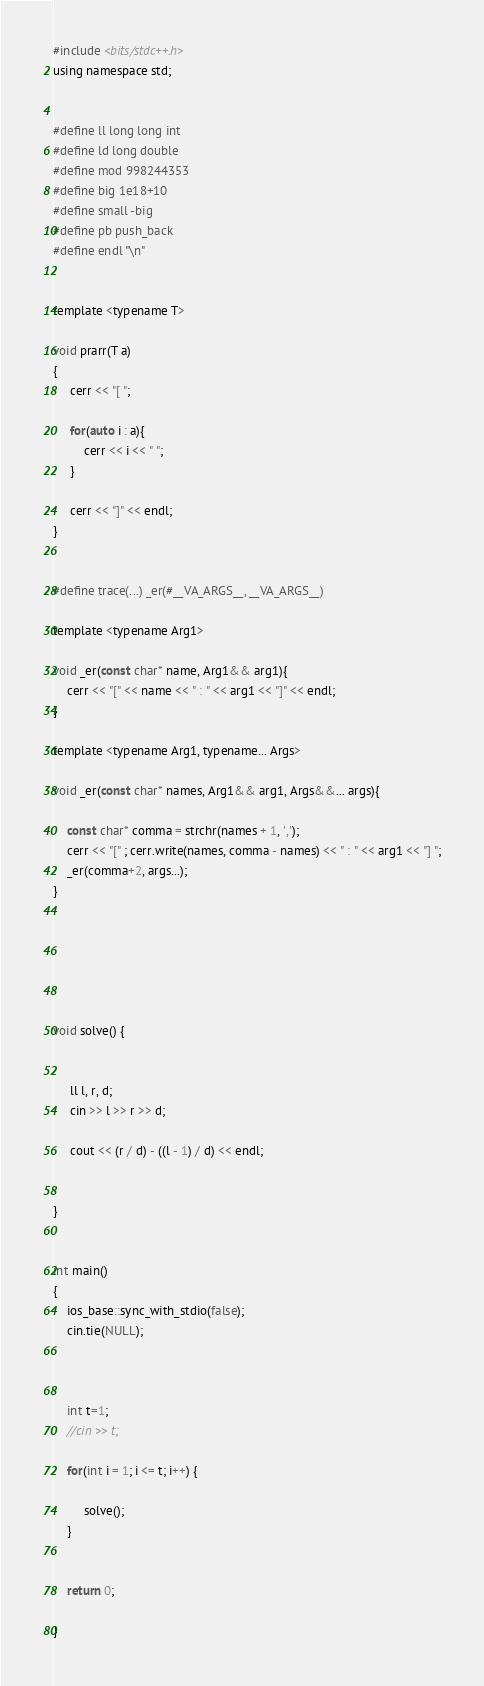<code> <loc_0><loc_0><loc_500><loc_500><_C_>

#include <bits/stdc++.h>
using namespace std;


#define ll long long int
#define ld long double
#define mod 998244353
#define big 1e18+10
#define small -big
#define pb push_back
#define endl "\n"


template <typename T>

void prarr(T a)
{
     cerr << "[ ";
     
     for(auto i : a){
         cerr << i << " ";
     }
     
     cerr << "]" << endl;
}


#define trace(...) _er(#__VA_ARGS__, __VA_ARGS__)

template <typename Arg1>

void _er(const char* name, Arg1&& arg1){
	cerr << "[" << name << " : " << arg1 << "]" << endl;
}

template <typename Arg1, typename... Args>

void _er(const char* names, Arg1&& arg1, Args&&... args){
    
	const char* comma = strchr(names + 1, ',');
	cerr << "[" ; cerr.write(names, comma - names) << " : " << arg1 << "] ";
	_er(comma+2, args...);
}






void solve() {
    
     
     ll l, r, d;
     cin >> l >> r >> d;
     
     cout << (r / d) - ((l - 1) / d) << endl;
    
    
}


int main()
{
    ios_base::sync_with_stdio(false);
    cin.tie(NULL);
    
   

    int t=1;
    //cin >> t;

    for(int i = 1; i <= t; i++) {  
   
         solve();
    }


    return 0;
        
}
</code> 